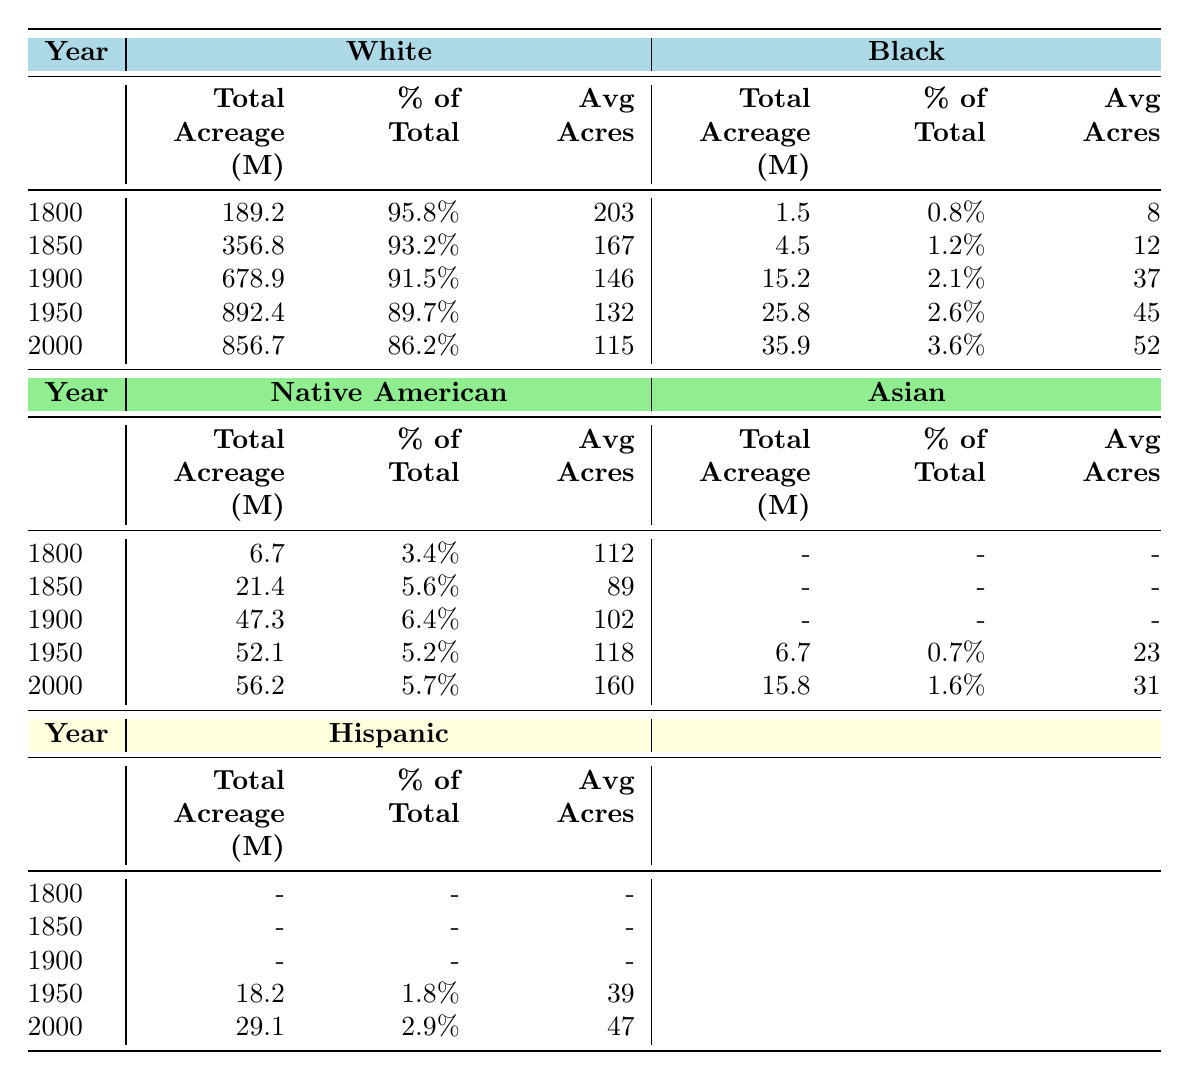What was the total acreage owned by White individuals in 1900? According to the table, the total acreage owned by White individuals in 1900 is listed as 678.9 million acres.
Answer: 678.9 million acres What is the percentage of total land owned by Native Americans in 1950? The table indicates that Native Americans owned 52.1 million acres in 1950, which is 5.2% of the total land.
Answer: 5.2% How many more acres did White individuals own than Black individuals in 2000? In 2000, White individuals owned 856.7 million acres and Black individuals owned 35.9 million acres. The difference is 856.7 - 35.9 = 820.8 million acres.
Answer: 820.8 million acres In which year did Black individuals first surpass 2% of total land ownership? The data for Black individuals shows that in 1900 they owned 15.2 million acres, which is 2.1% of total land. Therefore, this is the first year they surpassed 2%.
Answer: 1900 What was the total percentage of land owned by all groups (White, Black, Native American, Asian, and Hispanic) in 1950? In 1950, the percentages of total land ownership by groups are: White 89.7%, Black 2.6%, Native American 5.2%, Asian 0.7%, and Hispanic 1.8%. Adding them together gives 89.7 + 2.6 + 5.2 + 0.7 + 1.8 = 100%.
Answer: 100% Did the average acreage per landowner for Black individuals increase or decrease from 1900 to 2000? In 1900, the average acres per landowner for Black individuals was 37, while in 2000 it increased to 52. Therefore, there was an increase in the average acreage per landowner.
Answer: Increased What was the overall change in total acreage owned by Native Americans from 1800 to 2000? In 1800, Native Americans owned 6.7 million acres, and by 2000, they owned 56.2 million acres. The change is 56.2 - 6.7 = 49.5 million acres.
Answer: 49.5 million acres What was the difference in average acres per landowner between White individuals and Asians in 2000? In 2000, White individuals had an average of 115 acres per landowner, while Asians had an average of 31. The difference is 115 - 31 = 84 acres.
Answer: 84 acres How did the percentage of land owned by Hispanics change from 1950 to 2000? In 1950, Hispanics owned 1.8% of the land, while in 2000 they owned 2.9%. The change is 2.9 - 1.8 = 1.1%, indicating an increase.
Answer: Increased by 1.1% Is it true that the average acres per landowner for Native Americans was consistently higher than for Black individuals from 1800 to 2000? Reviewing the data, Native Americans had an average of 112 acres in 1800, rising to 160 acres in 2000. Black individuals had averages of 8 in 1800, rising to 52 in 2000. Thus, Native Americans always had a higher average.
Answer: True 